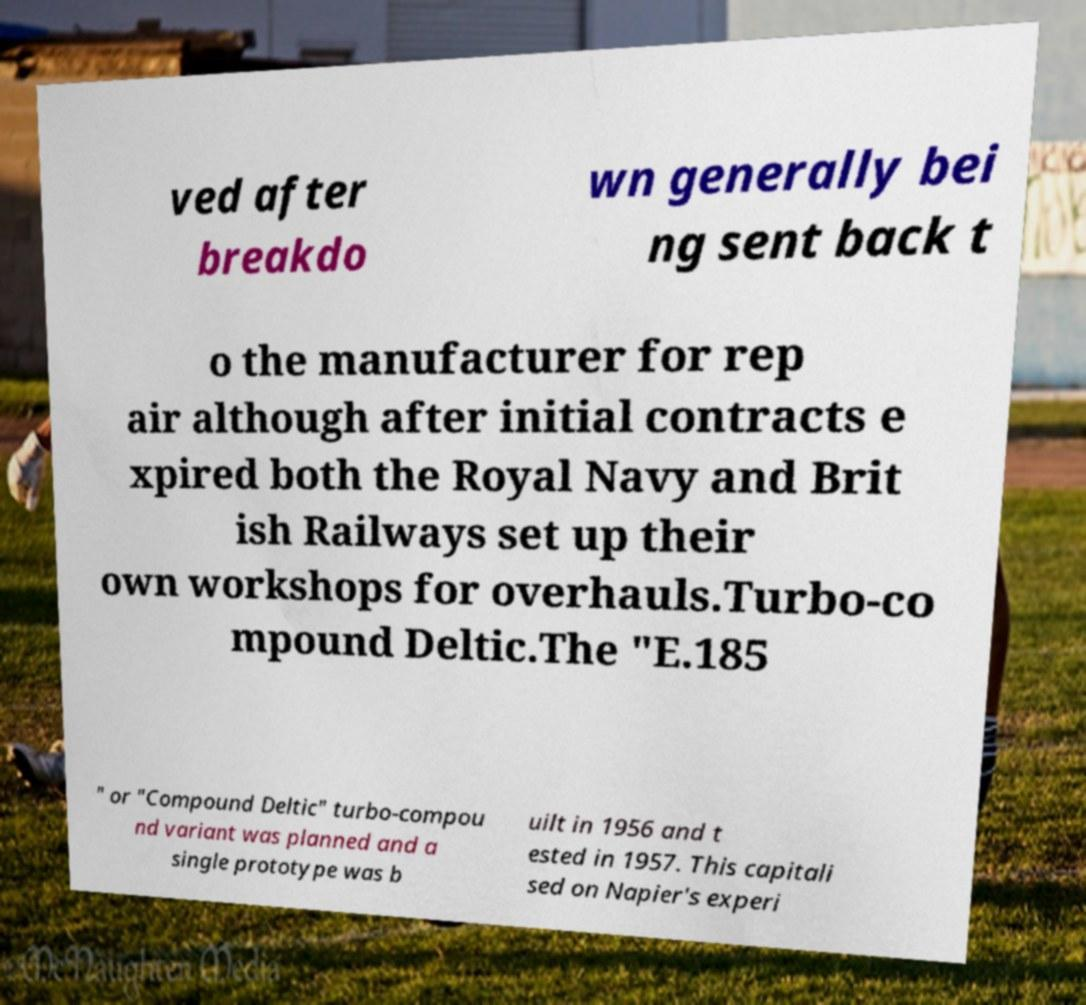Can you read and provide the text displayed in the image?This photo seems to have some interesting text. Can you extract and type it out for me? ved after breakdo wn generally bei ng sent back t o the manufacturer for rep air although after initial contracts e xpired both the Royal Navy and Brit ish Railways set up their own workshops for overhauls.Turbo-co mpound Deltic.The "E.185 " or "Compound Deltic" turbo-compou nd variant was planned and a single prototype was b uilt in 1956 and t ested in 1957. This capitali sed on Napier's experi 